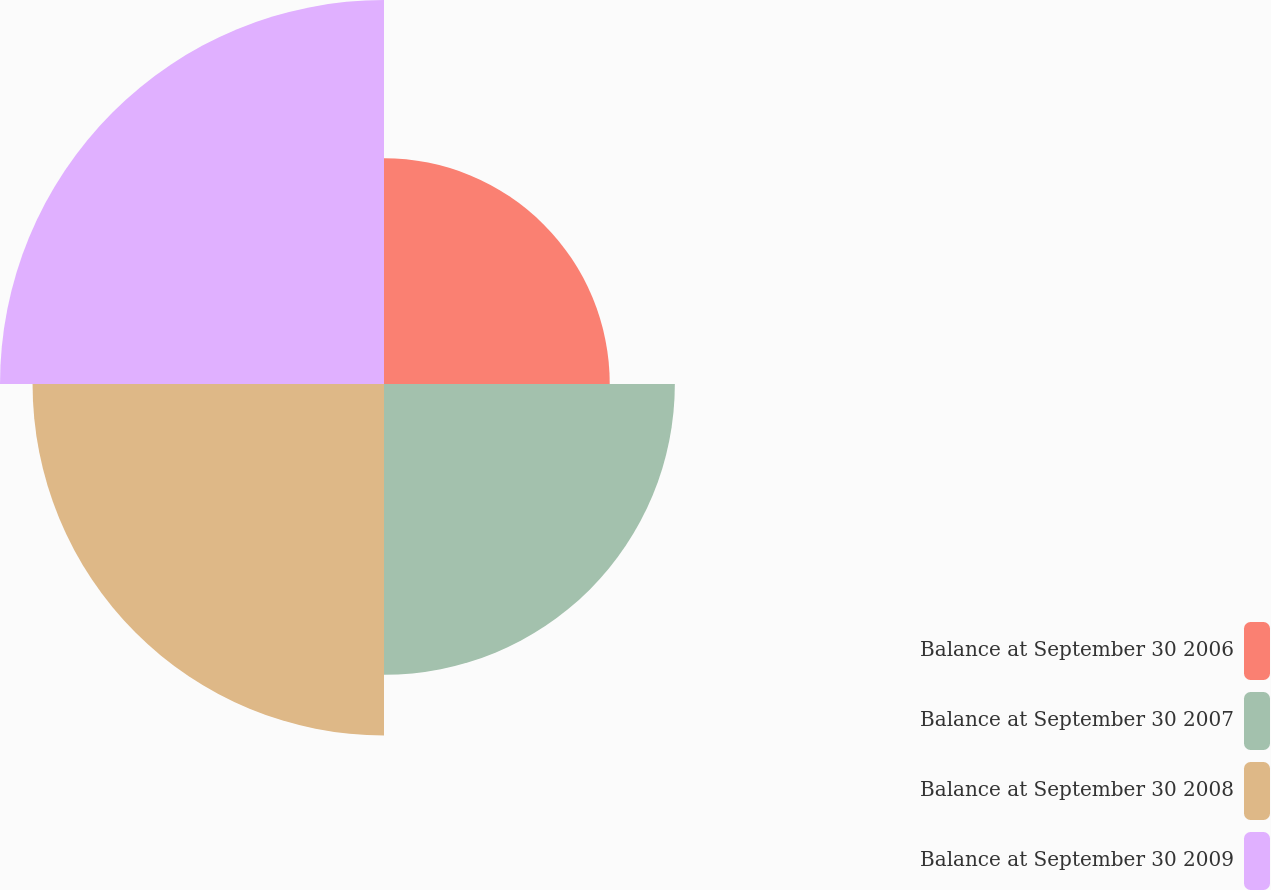Convert chart. <chart><loc_0><loc_0><loc_500><loc_500><pie_chart><fcel>Balance at September 30 2006<fcel>Balance at September 30 2007<fcel>Balance at September 30 2008<fcel>Balance at September 30 2009<nl><fcel>18.03%<fcel>23.23%<fcel>28.07%<fcel>30.67%<nl></chart> 